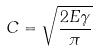Convert formula to latex. <formula><loc_0><loc_0><loc_500><loc_500>C = \sqrt { \frac { 2 E \gamma } { \pi } }</formula> 